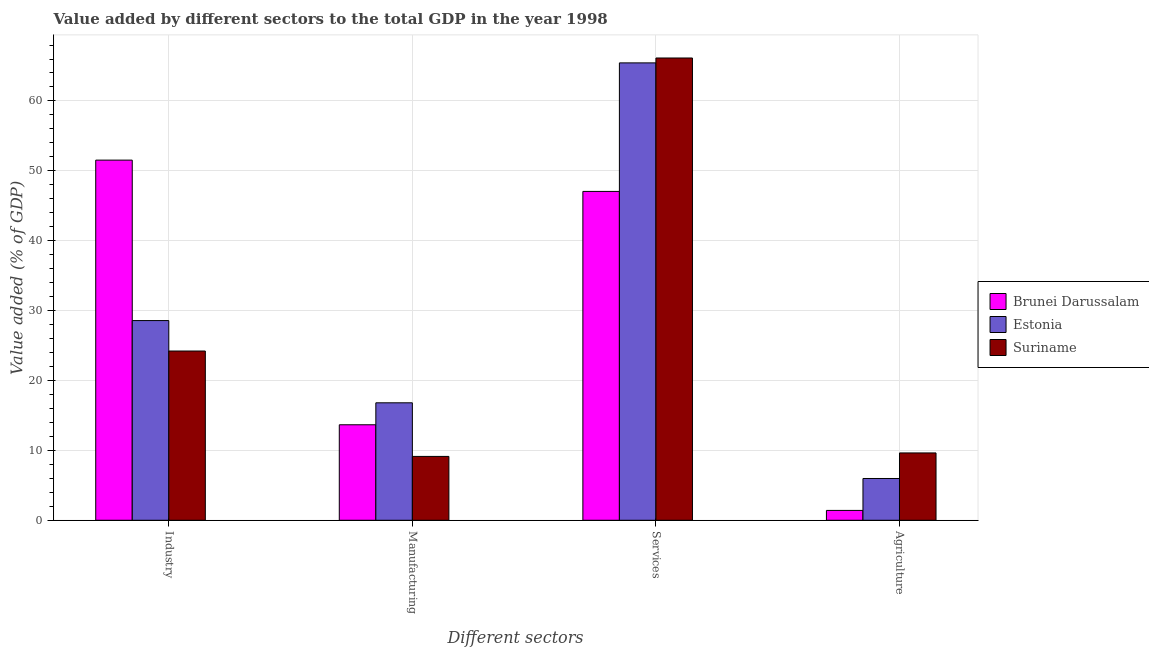How many groups of bars are there?
Provide a succinct answer. 4. How many bars are there on the 1st tick from the right?
Your answer should be compact. 3. What is the label of the 3rd group of bars from the left?
Your answer should be compact. Services. What is the value added by services sector in Suriname?
Your answer should be compact. 66.15. Across all countries, what is the maximum value added by services sector?
Provide a succinct answer. 66.15. Across all countries, what is the minimum value added by manufacturing sector?
Ensure brevity in your answer.  9.14. In which country was the value added by services sector maximum?
Your response must be concise. Suriname. In which country was the value added by services sector minimum?
Your answer should be very brief. Brunei Darussalam. What is the total value added by agricultural sector in the graph?
Offer a very short reply. 17.02. What is the difference between the value added by industrial sector in Estonia and that in Suriname?
Your response must be concise. 4.36. What is the difference between the value added by manufacturing sector in Suriname and the value added by agricultural sector in Estonia?
Ensure brevity in your answer.  3.16. What is the average value added by agricultural sector per country?
Provide a short and direct response. 5.67. What is the difference between the value added by industrial sector and value added by services sector in Estonia?
Make the answer very short. -36.87. In how many countries, is the value added by manufacturing sector greater than 8 %?
Offer a terse response. 3. What is the ratio of the value added by industrial sector in Suriname to that in Brunei Darussalam?
Your answer should be compact. 0.47. What is the difference between the highest and the second highest value added by services sector?
Give a very brief answer. 0.7. What is the difference between the highest and the lowest value added by services sector?
Provide a short and direct response. 19.09. Is the sum of the value added by services sector in Brunei Darussalam and Suriname greater than the maximum value added by industrial sector across all countries?
Your answer should be compact. Yes. What does the 2nd bar from the left in Industry represents?
Ensure brevity in your answer.  Estonia. What does the 2nd bar from the right in Services represents?
Keep it short and to the point. Estonia. Is it the case that in every country, the sum of the value added by industrial sector and value added by manufacturing sector is greater than the value added by services sector?
Offer a very short reply. No. Are all the bars in the graph horizontal?
Your answer should be very brief. No. What is the difference between two consecutive major ticks on the Y-axis?
Ensure brevity in your answer.  10. Are the values on the major ticks of Y-axis written in scientific E-notation?
Your answer should be very brief. No. Does the graph contain any zero values?
Keep it short and to the point. No. How are the legend labels stacked?
Ensure brevity in your answer.  Vertical. What is the title of the graph?
Your response must be concise. Value added by different sectors to the total GDP in the year 1998. Does "Argentina" appear as one of the legend labels in the graph?
Offer a terse response. No. What is the label or title of the X-axis?
Ensure brevity in your answer.  Different sectors. What is the label or title of the Y-axis?
Offer a terse response. Value added (% of GDP). What is the Value added (% of GDP) in Brunei Darussalam in Industry?
Your answer should be compact. 51.53. What is the Value added (% of GDP) of Estonia in Industry?
Keep it short and to the point. 28.58. What is the Value added (% of GDP) in Suriname in Industry?
Your answer should be very brief. 24.22. What is the Value added (% of GDP) of Brunei Darussalam in Manufacturing?
Give a very brief answer. 13.66. What is the Value added (% of GDP) of Estonia in Manufacturing?
Offer a very short reply. 16.81. What is the Value added (% of GDP) of Suriname in Manufacturing?
Offer a terse response. 9.14. What is the Value added (% of GDP) of Brunei Darussalam in Services?
Make the answer very short. 47.06. What is the Value added (% of GDP) in Estonia in Services?
Ensure brevity in your answer.  65.45. What is the Value added (% of GDP) in Suriname in Services?
Ensure brevity in your answer.  66.15. What is the Value added (% of GDP) of Brunei Darussalam in Agriculture?
Ensure brevity in your answer.  1.41. What is the Value added (% of GDP) in Estonia in Agriculture?
Give a very brief answer. 5.98. What is the Value added (% of GDP) in Suriname in Agriculture?
Your response must be concise. 9.63. Across all Different sectors, what is the maximum Value added (% of GDP) in Brunei Darussalam?
Give a very brief answer. 51.53. Across all Different sectors, what is the maximum Value added (% of GDP) in Estonia?
Ensure brevity in your answer.  65.45. Across all Different sectors, what is the maximum Value added (% of GDP) of Suriname?
Keep it short and to the point. 66.15. Across all Different sectors, what is the minimum Value added (% of GDP) in Brunei Darussalam?
Provide a succinct answer. 1.41. Across all Different sectors, what is the minimum Value added (% of GDP) of Estonia?
Offer a terse response. 5.98. Across all Different sectors, what is the minimum Value added (% of GDP) of Suriname?
Your answer should be very brief. 9.14. What is the total Value added (% of GDP) of Brunei Darussalam in the graph?
Your answer should be compact. 113.66. What is the total Value added (% of GDP) of Estonia in the graph?
Make the answer very short. 116.81. What is the total Value added (% of GDP) of Suriname in the graph?
Your answer should be compact. 109.14. What is the difference between the Value added (% of GDP) of Brunei Darussalam in Industry and that in Manufacturing?
Give a very brief answer. 37.87. What is the difference between the Value added (% of GDP) in Estonia in Industry and that in Manufacturing?
Keep it short and to the point. 11.77. What is the difference between the Value added (% of GDP) of Suriname in Industry and that in Manufacturing?
Offer a terse response. 15.08. What is the difference between the Value added (% of GDP) in Brunei Darussalam in Industry and that in Services?
Offer a terse response. 4.48. What is the difference between the Value added (% of GDP) in Estonia in Industry and that in Services?
Make the answer very short. -36.87. What is the difference between the Value added (% of GDP) of Suriname in Industry and that in Services?
Your answer should be compact. -41.93. What is the difference between the Value added (% of GDP) of Brunei Darussalam in Industry and that in Agriculture?
Provide a succinct answer. 50.12. What is the difference between the Value added (% of GDP) of Estonia in Industry and that in Agriculture?
Your response must be concise. 22.6. What is the difference between the Value added (% of GDP) in Suriname in Industry and that in Agriculture?
Your response must be concise. 14.58. What is the difference between the Value added (% of GDP) in Brunei Darussalam in Manufacturing and that in Services?
Your answer should be compact. -33.39. What is the difference between the Value added (% of GDP) of Estonia in Manufacturing and that in Services?
Offer a very short reply. -48.64. What is the difference between the Value added (% of GDP) of Suriname in Manufacturing and that in Services?
Offer a terse response. -57.01. What is the difference between the Value added (% of GDP) in Brunei Darussalam in Manufacturing and that in Agriculture?
Offer a terse response. 12.25. What is the difference between the Value added (% of GDP) of Estonia in Manufacturing and that in Agriculture?
Provide a short and direct response. 10.83. What is the difference between the Value added (% of GDP) in Suriname in Manufacturing and that in Agriculture?
Your response must be concise. -0.5. What is the difference between the Value added (% of GDP) of Brunei Darussalam in Services and that in Agriculture?
Your response must be concise. 45.65. What is the difference between the Value added (% of GDP) of Estonia in Services and that in Agriculture?
Keep it short and to the point. 59.47. What is the difference between the Value added (% of GDP) of Suriname in Services and that in Agriculture?
Offer a terse response. 56.51. What is the difference between the Value added (% of GDP) in Brunei Darussalam in Industry and the Value added (% of GDP) in Estonia in Manufacturing?
Your answer should be compact. 34.73. What is the difference between the Value added (% of GDP) in Brunei Darussalam in Industry and the Value added (% of GDP) in Suriname in Manufacturing?
Provide a short and direct response. 42.4. What is the difference between the Value added (% of GDP) in Estonia in Industry and the Value added (% of GDP) in Suriname in Manufacturing?
Your response must be concise. 19.44. What is the difference between the Value added (% of GDP) of Brunei Darussalam in Industry and the Value added (% of GDP) of Estonia in Services?
Your response must be concise. -13.91. What is the difference between the Value added (% of GDP) in Brunei Darussalam in Industry and the Value added (% of GDP) in Suriname in Services?
Your answer should be very brief. -14.61. What is the difference between the Value added (% of GDP) in Estonia in Industry and the Value added (% of GDP) in Suriname in Services?
Offer a very short reply. -37.57. What is the difference between the Value added (% of GDP) in Brunei Darussalam in Industry and the Value added (% of GDP) in Estonia in Agriculture?
Your answer should be compact. 45.56. What is the difference between the Value added (% of GDP) of Brunei Darussalam in Industry and the Value added (% of GDP) of Suriname in Agriculture?
Your response must be concise. 41.9. What is the difference between the Value added (% of GDP) in Estonia in Industry and the Value added (% of GDP) in Suriname in Agriculture?
Ensure brevity in your answer.  18.94. What is the difference between the Value added (% of GDP) in Brunei Darussalam in Manufacturing and the Value added (% of GDP) in Estonia in Services?
Your answer should be compact. -51.78. What is the difference between the Value added (% of GDP) of Brunei Darussalam in Manufacturing and the Value added (% of GDP) of Suriname in Services?
Give a very brief answer. -52.48. What is the difference between the Value added (% of GDP) in Estonia in Manufacturing and the Value added (% of GDP) in Suriname in Services?
Provide a short and direct response. -49.34. What is the difference between the Value added (% of GDP) of Brunei Darussalam in Manufacturing and the Value added (% of GDP) of Estonia in Agriculture?
Your answer should be very brief. 7.69. What is the difference between the Value added (% of GDP) in Brunei Darussalam in Manufacturing and the Value added (% of GDP) in Suriname in Agriculture?
Your answer should be very brief. 4.03. What is the difference between the Value added (% of GDP) in Estonia in Manufacturing and the Value added (% of GDP) in Suriname in Agriculture?
Your answer should be very brief. 7.17. What is the difference between the Value added (% of GDP) in Brunei Darussalam in Services and the Value added (% of GDP) in Estonia in Agriculture?
Provide a succinct answer. 41.08. What is the difference between the Value added (% of GDP) of Brunei Darussalam in Services and the Value added (% of GDP) of Suriname in Agriculture?
Your response must be concise. 37.42. What is the difference between the Value added (% of GDP) of Estonia in Services and the Value added (% of GDP) of Suriname in Agriculture?
Give a very brief answer. 55.81. What is the average Value added (% of GDP) of Brunei Darussalam per Different sectors?
Keep it short and to the point. 28.42. What is the average Value added (% of GDP) in Estonia per Different sectors?
Your response must be concise. 29.2. What is the average Value added (% of GDP) of Suriname per Different sectors?
Your response must be concise. 27.28. What is the difference between the Value added (% of GDP) of Brunei Darussalam and Value added (% of GDP) of Estonia in Industry?
Your answer should be very brief. 22.96. What is the difference between the Value added (% of GDP) in Brunei Darussalam and Value added (% of GDP) in Suriname in Industry?
Your answer should be compact. 27.32. What is the difference between the Value added (% of GDP) of Estonia and Value added (% of GDP) of Suriname in Industry?
Your answer should be very brief. 4.36. What is the difference between the Value added (% of GDP) in Brunei Darussalam and Value added (% of GDP) in Estonia in Manufacturing?
Offer a terse response. -3.14. What is the difference between the Value added (% of GDP) in Brunei Darussalam and Value added (% of GDP) in Suriname in Manufacturing?
Make the answer very short. 4.53. What is the difference between the Value added (% of GDP) in Estonia and Value added (% of GDP) in Suriname in Manufacturing?
Give a very brief answer. 7.67. What is the difference between the Value added (% of GDP) in Brunei Darussalam and Value added (% of GDP) in Estonia in Services?
Provide a short and direct response. -18.39. What is the difference between the Value added (% of GDP) of Brunei Darussalam and Value added (% of GDP) of Suriname in Services?
Your answer should be very brief. -19.09. What is the difference between the Value added (% of GDP) of Estonia and Value added (% of GDP) of Suriname in Services?
Your answer should be very brief. -0.7. What is the difference between the Value added (% of GDP) in Brunei Darussalam and Value added (% of GDP) in Estonia in Agriculture?
Give a very brief answer. -4.57. What is the difference between the Value added (% of GDP) in Brunei Darussalam and Value added (% of GDP) in Suriname in Agriculture?
Ensure brevity in your answer.  -8.22. What is the difference between the Value added (% of GDP) in Estonia and Value added (% of GDP) in Suriname in Agriculture?
Provide a succinct answer. -3.66. What is the ratio of the Value added (% of GDP) in Brunei Darussalam in Industry to that in Manufacturing?
Ensure brevity in your answer.  3.77. What is the ratio of the Value added (% of GDP) of Estonia in Industry to that in Manufacturing?
Offer a very short reply. 1.7. What is the ratio of the Value added (% of GDP) of Suriname in Industry to that in Manufacturing?
Provide a short and direct response. 2.65. What is the ratio of the Value added (% of GDP) of Brunei Darussalam in Industry to that in Services?
Offer a terse response. 1.1. What is the ratio of the Value added (% of GDP) of Estonia in Industry to that in Services?
Give a very brief answer. 0.44. What is the ratio of the Value added (% of GDP) in Suriname in Industry to that in Services?
Offer a terse response. 0.37. What is the ratio of the Value added (% of GDP) in Brunei Darussalam in Industry to that in Agriculture?
Provide a short and direct response. 36.54. What is the ratio of the Value added (% of GDP) in Estonia in Industry to that in Agriculture?
Your response must be concise. 4.78. What is the ratio of the Value added (% of GDP) in Suriname in Industry to that in Agriculture?
Keep it short and to the point. 2.51. What is the ratio of the Value added (% of GDP) in Brunei Darussalam in Manufacturing to that in Services?
Offer a terse response. 0.29. What is the ratio of the Value added (% of GDP) in Estonia in Manufacturing to that in Services?
Your answer should be compact. 0.26. What is the ratio of the Value added (% of GDP) in Suriname in Manufacturing to that in Services?
Provide a short and direct response. 0.14. What is the ratio of the Value added (% of GDP) of Brunei Darussalam in Manufacturing to that in Agriculture?
Offer a very short reply. 9.69. What is the ratio of the Value added (% of GDP) in Estonia in Manufacturing to that in Agriculture?
Make the answer very short. 2.81. What is the ratio of the Value added (% of GDP) of Suriname in Manufacturing to that in Agriculture?
Provide a short and direct response. 0.95. What is the ratio of the Value added (% of GDP) of Brunei Darussalam in Services to that in Agriculture?
Your response must be concise. 33.37. What is the ratio of the Value added (% of GDP) in Estonia in Services to that in Agriculture?
Keep it short and to the point. 10.95. What is the ratio of the Value added (% of GDP) of Suriname in Services to that in Agriculture?
Your answer should be compact. 6.87. What is the difference between the highest and the second highest Value added (% of GDP) of Brunei Darussalam?
Offer a very short reply. 4.48. What is the difference between the highest and the second highest Value added (% of GDP) of Estonia?
Offer a very short reply. 36.87. What is the difference between the highest and the second highest Value added (% of GDP) in Suriname?
Your answer should be compact. 41.93. What is the difference between the highest and the lowest Value added (% of GDP) in Brunei Darussalam?
Keep it short and to the point. 50.12. What is the difference between the highest and the lowest Value added (% of GDP) of Estonia?
Provide a succinct answer. 59.47. What is the difference between the highest and the lowest Value added (% of GDP) of Suriname?
Provide a succinct answer. 57.01. 